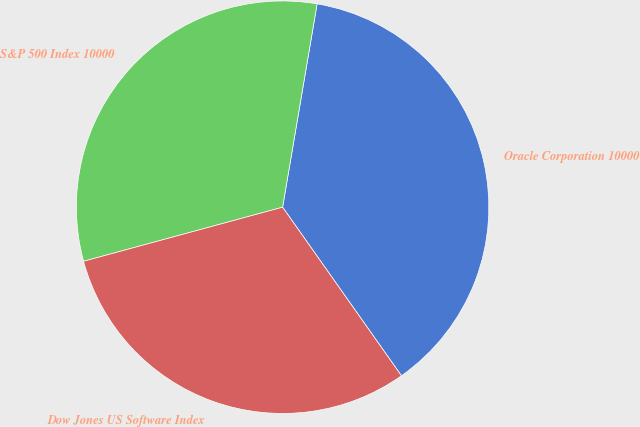Convert chart. <chart><loc_0><loc_0><loc_500><loc_500><pie_chart><fcel>Oracle Corporation 10000<fcel>S&P 500 Index 10000<fcel>Dow Jones US Software Index<nl><fcel>37.55%<fcel>31.9%<fcel>30.55%<nl></chart> 